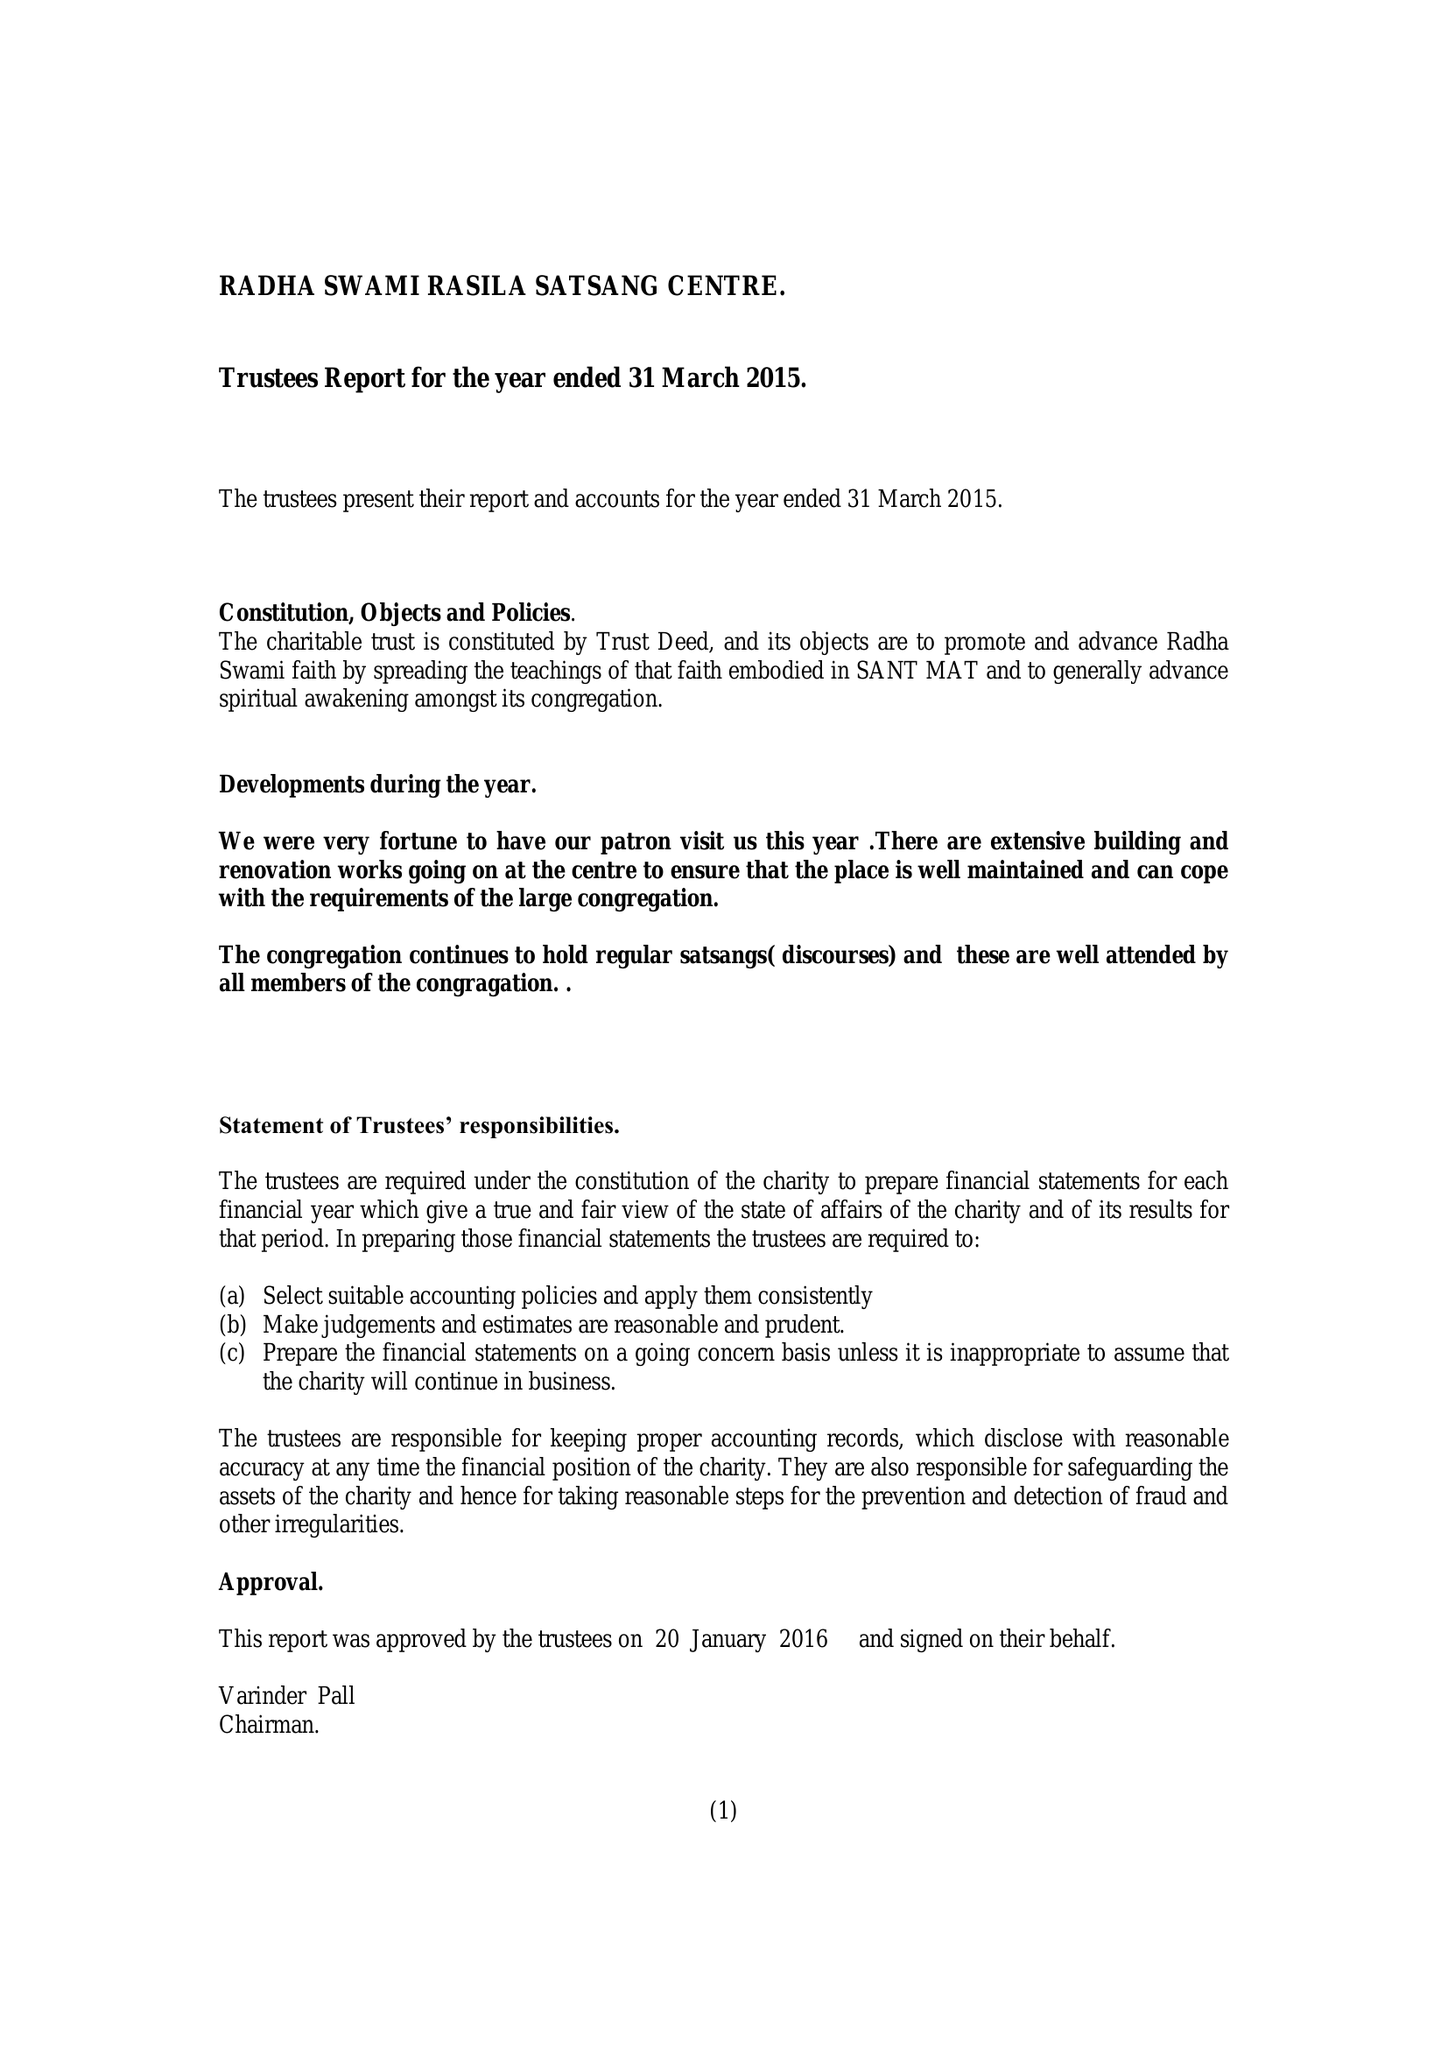What is the value for the charity_number?
Answer the question using a single word or phrase. 1045942 